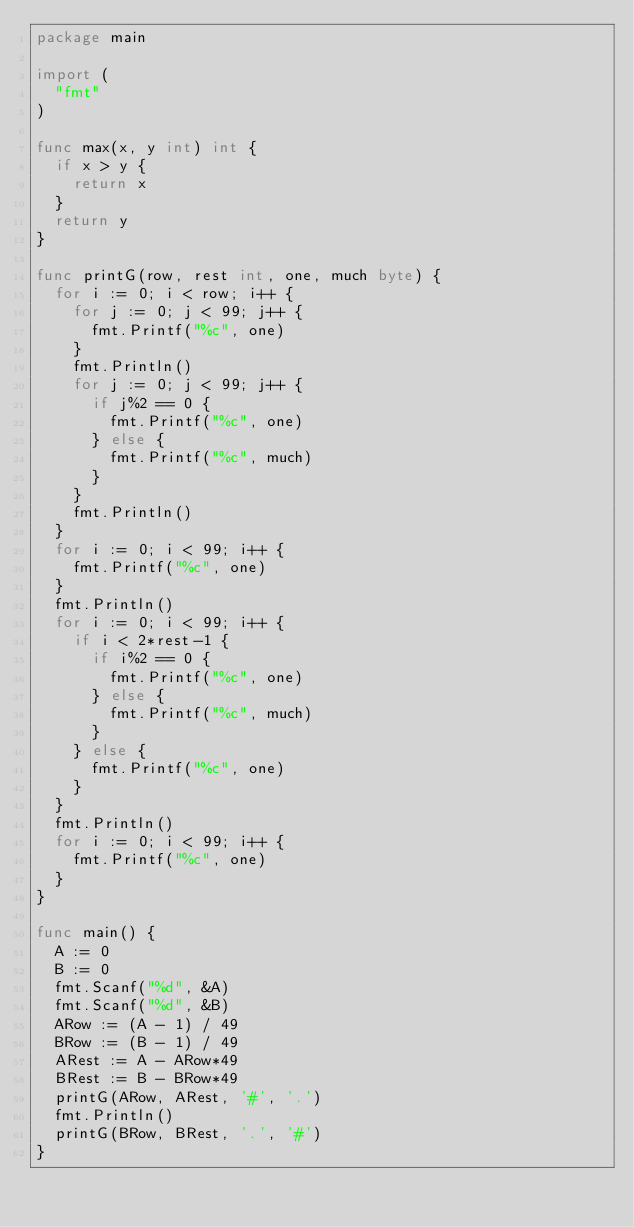<code> <loc_0><loc_0><loc_500><loc_500><_Go_>package main

import (
	"fmt"
)

func max(x, y int) int {
	if x > y {
		return x
	}
	return y
}

func printG(row, rest int, one, much byte) {
	for i := 0; i < row; i++ {
		for j := 0; j < 99; j++ {
			fmt.Printf("%c", one)
		}
		fmt.Println()
		for j := 0; j < 99; j++ {
			if j%2 == 0 {
				fmt.Printf("%c", one)
			} else {
				fmt.Printf("%c", much)
			}
		}
		fmt.Println()
	}
	for i := 0; i < 99; i++ {
		fmt.Printf("%c", one)
	}
	fmt.Println()
	for i := 0; i < 99; i++ {
		if i < 2*rest-1 {
			if i%2 == 0 {
				fmt.Printf("%c", one)
			} else {
				fmt.Printf("%c", much)
			}
		} else {
			fmt.Printf("%c", one)
		}
	}
	fmt.Println()
	for i := 0; i < 99; i++ {
		fmt.Printf("%c", one)
	}
}

func main() {
	A := 0
	B := 0
	fmt.Scanf("%d", &A)
	fmt.Scanf("%d", &B)
	ARow := (A - 1) / 49
	BRow := (B - 1) / 49
	ARest := A - ARow*49
	BRest := B - BRow*49
	printG(ARow, ARest, '#', '.')
	fmt.Println()
	printG(BRow, BRest, '.', '#')
}
</code> 